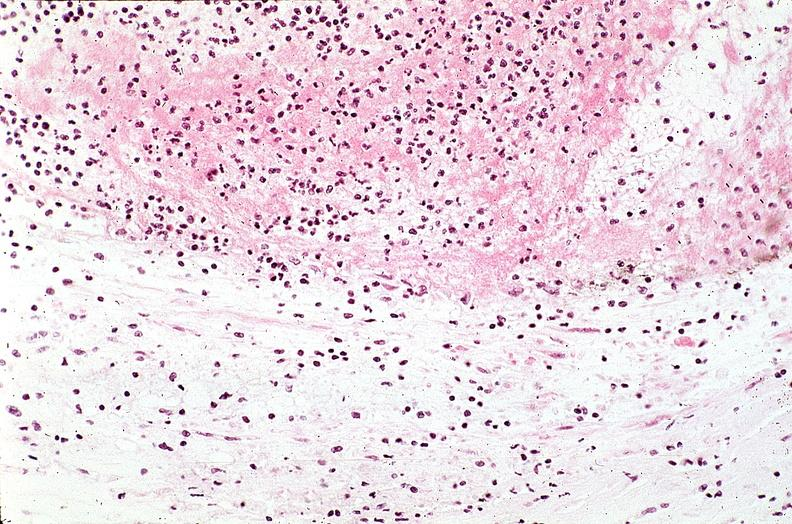what does this image show?
Answer the question using a single word or phrase. Coronary artery with atherosclerosis and thrombotic occlusion 